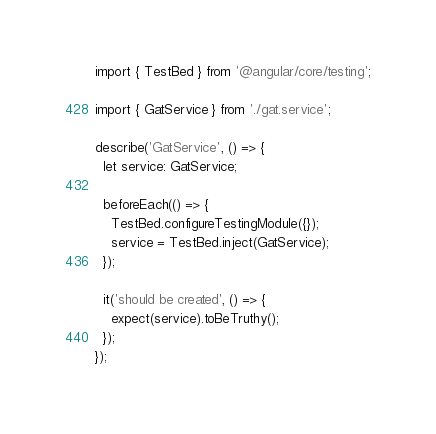<code> <loc_0><loc_0><loc_500><loc_500><_TypeScript_>import { TestBed } from '@angular/core/testing';

import { GatService } from './gat.service';

describe('GatService', () => {
  let service: GatService;

  beforeEach(() => {
    TestBed.configureTestingModule({});
    service = TestBed.inject(GatService);
  });

  it('should be created', () => {
    expect(service).toBeTruthy();
  });
});
</code> 